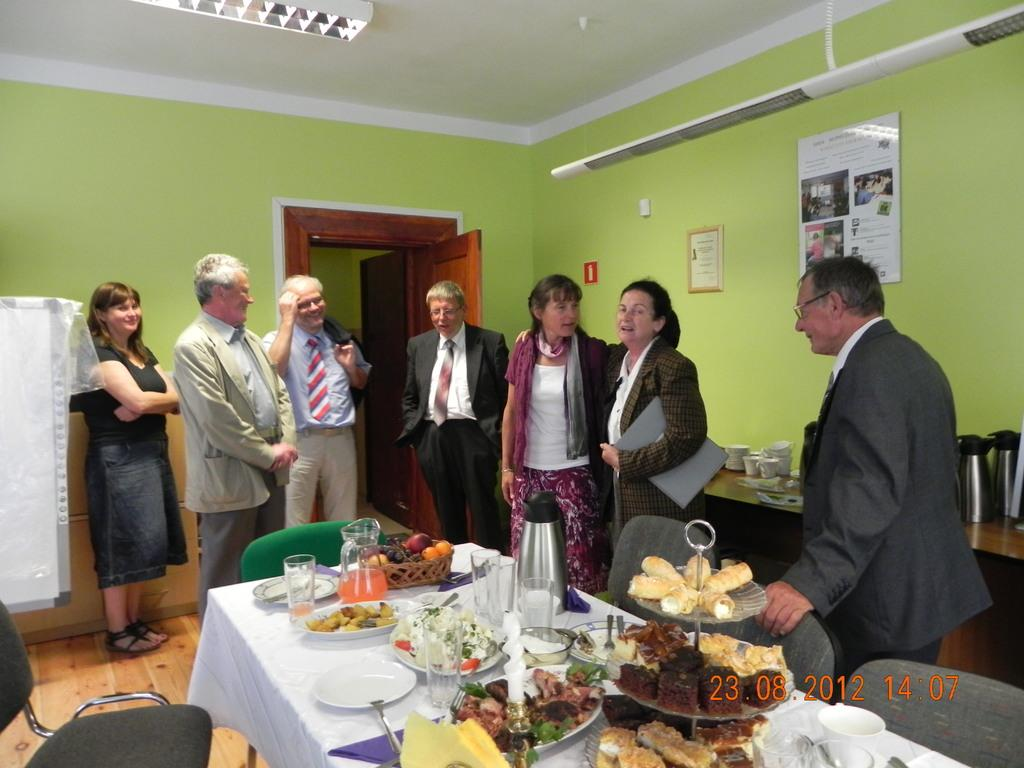How many people are in the image? There are people in the image, but the exact number cannot be determined from the provided facts. What are the people doing in the image? The people are standing in front of a table, but their specific actions are not mentioned. What can be found on the table in the image? There are food items and other things placed on the table. What type of organization is represented by the rabbits in the image? There are no rabbits present in the image, so it is not possible to determine the type of organization they might represent. 